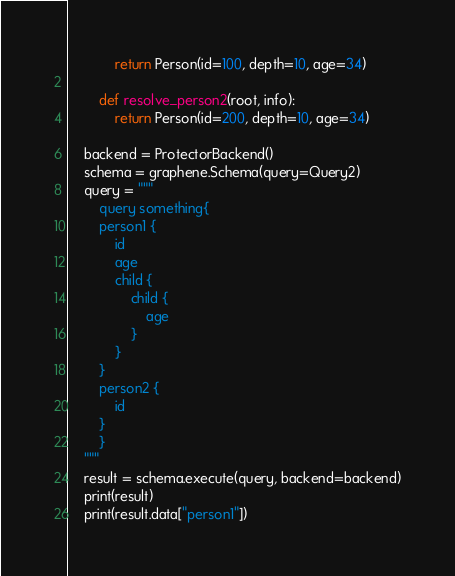Convert code to text. <code><loc_0><loc_0><loc_500><loc_500><_Python_>            return Person(id=100, depth=10, age=34)

        def resolve_person2(root, info):
            return Person(id=200, depth=10, age=34)

    backend = ProtectorBackend()
    schema = graphene.Schema(query=Query2)
    query = """
        query something{
        person1 {
            id
            age
            child {
                child {
                    age
                }
            }
        }
        person2 {
            id
        }
        }
    """
    result = schema.execute(query, backend=backend)
    print(result)
    print(result.data["person1"])
</code> 